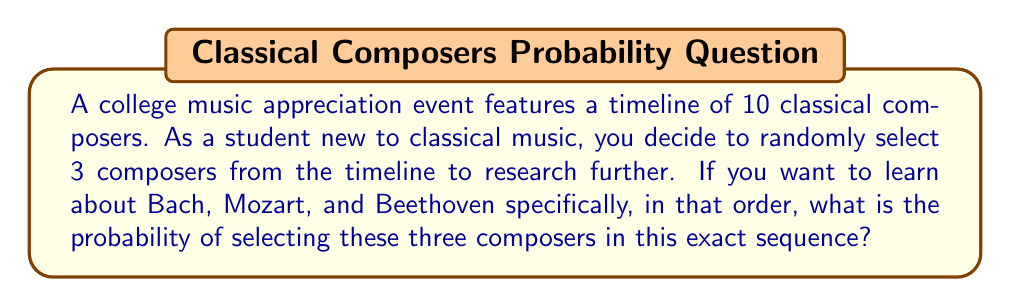Solve this math problem. Let's approach this step-by-step:

1) First, we need to understand what the question is asking. We're looking for the probability of selecting Bach, then Mozart, then Beethoven, in that specific order, out of 10 composers.

2) This is a problem of ordered selection without replacement. Each selection reduces the number of composers available for the next selection.

3) For the first selection (Bach):
   - There are 10 composers to choose from, and only 1 is Bach.
   - The probability of selecting Bach first is $\frac{1}{10}$.

4) For the second selection (Mozart):
   - There are now 9 composers left, and only 1 is Mozart.
   - The probability of selecting Mozart second is $\frac{1}{9}$.

5) For the third selection (Beethoven):
   - There are now 8 composers left, and only 1 is Beethoven.
   - The probability of selecting Beethoven third is $\frac{1}{8}$.

6) To find the probability of all these events occurring in this specific sequence, we multiply the individual probabilities:

   $$P(\text{Bach, then Mozart, then Beethoven}) = \frac{1}{10} \times \frac{1}{9} \times \frac{1}{8}$$

7) Simplifying:
   $$P = \frac{1}{720}$$

Therefore, the probability of randomly selecting Bach, Mozart, and Beethoven in that specific order is $\frac{1}{720}$.
Answer: $\frac{1}{720}$ 